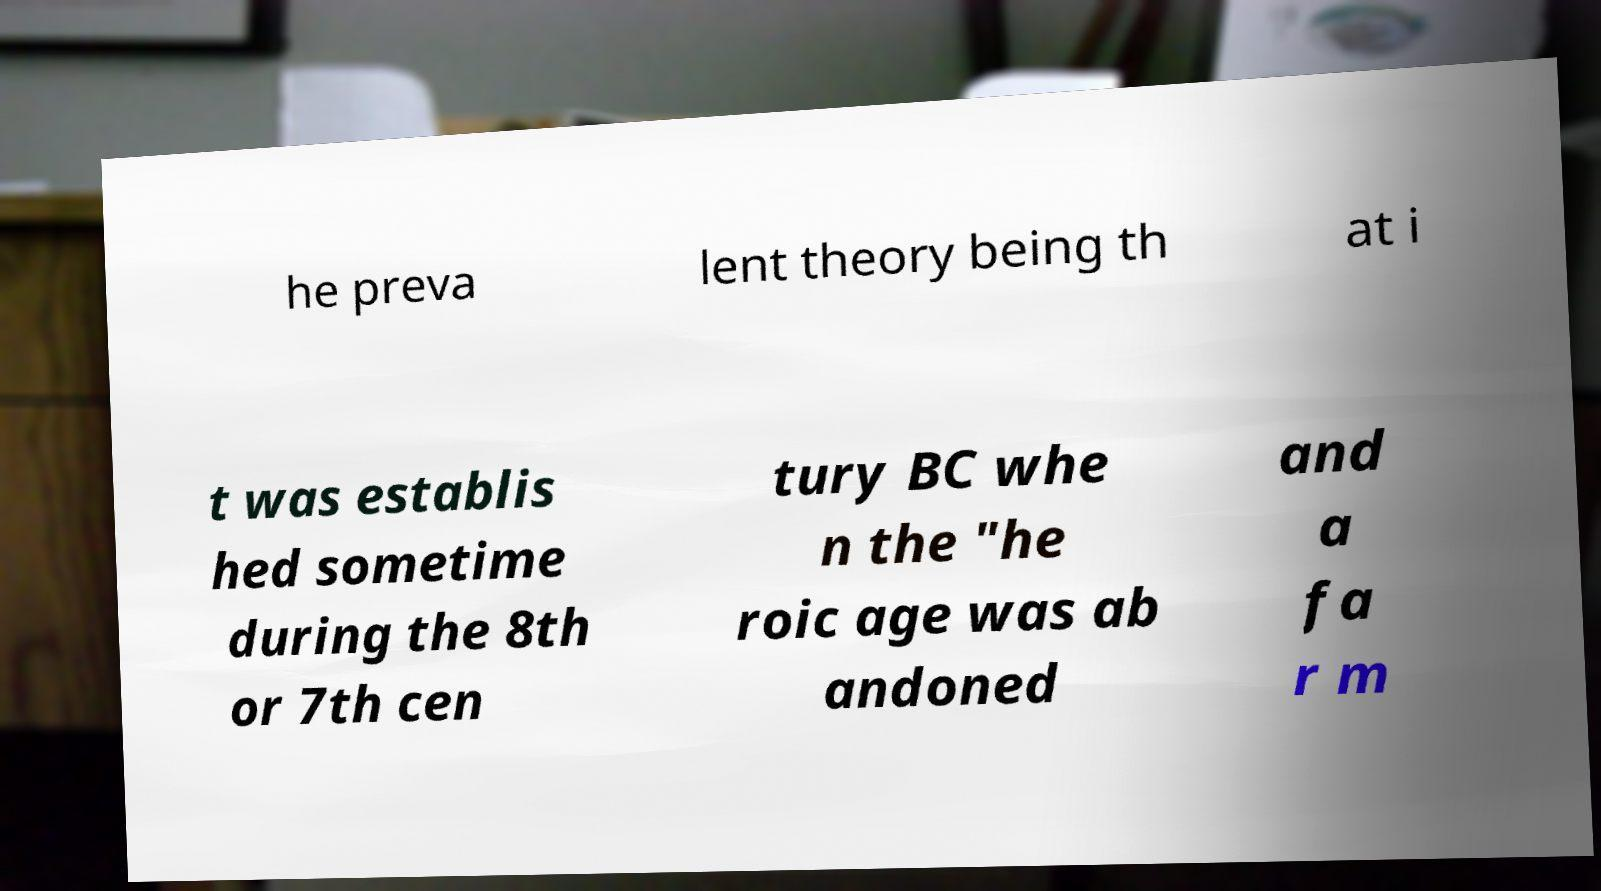What messages or text are displayed in this image? I need them in a readable, typed format. he preva lent theory being th at i t was establis hed sometime during the 8th or 7th cen tury BC whe n the "he roic age was ab andoned and a fa r m 